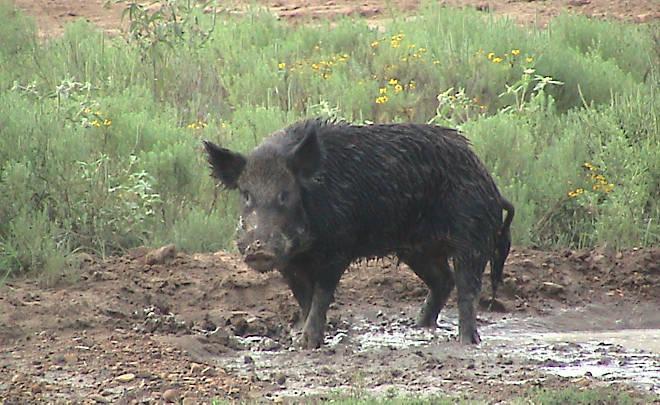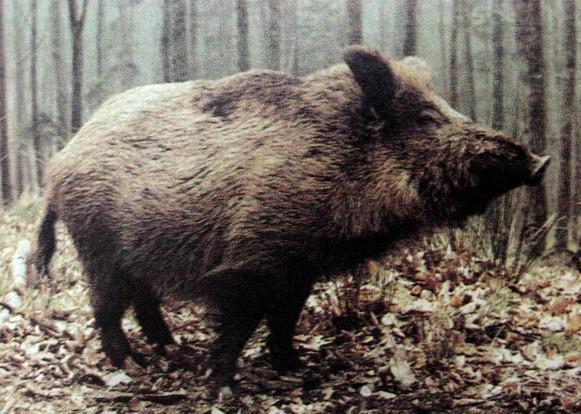The first image is the image on the left, the second image is the image on the right. Assess this claim about the two images: "The left image contains at least four boars.". Correct or not? Answer yes or no. No. The first image is the image on the left, the second image is the image on the right. Considering the images on both sides, is "An image includes at least three striped baby pigs next to a standing adult wild hog." valid? Answer yes or no. No. 